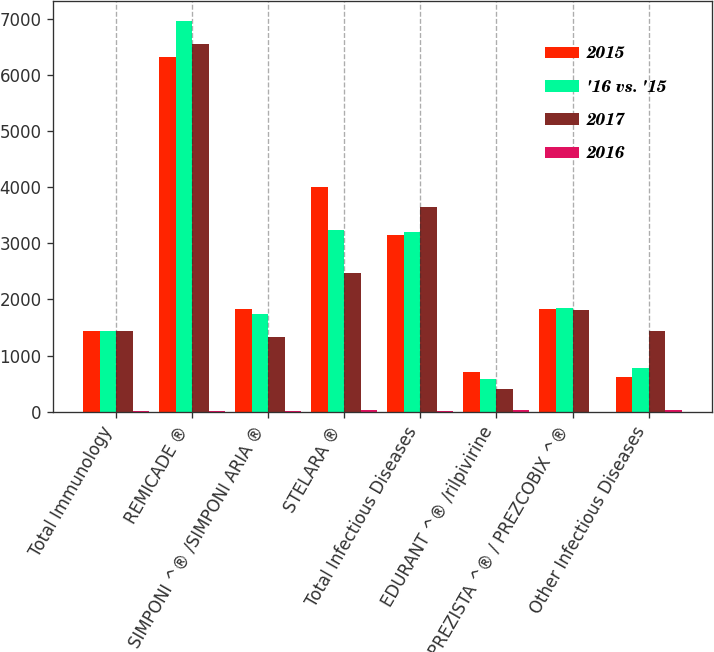<chart> <loc_0><loc_0><loc_500><loc_500><stacked_bar_chart><ecel><fcel>Total Immunology<fcel>REMICADE ®<fcel>SIMPONI ^® /SIMPONI ARIA ®<fcel>STELARA ®<fcel>Total Infectious Diseases<fcel>EDURANT ^® /rilpivirine<fcel>PREZISTA ^® / PREZCOBIX ^®<fcel>Other Infectious Diseases<nl><fcel>2015<fcel>1436<fcel>6315<fcel>1833<fcel>4011<fcel>3154<fcel>714<fcel>1821<fcel>619<nl><fcel>'16 vs. '15<fcel>1436<fcel>6966<fcel>1745<fcel>3232<fcel>3208<fcel>573<fcel>1851<fcel>784<nl><fcel>2017<fcel>1436<fcel>6561<fcel>1328<fcel>2474<fcel>3656<fcel>410<fcel>1810<fcel>1436<nl><fcel>2016<fcel>2.3<fcel>9.3<fcel>5<fcel>24.1<fcel>1.7<fcel>24.6<fcel>1.6<fcel>21<nl></chart> 